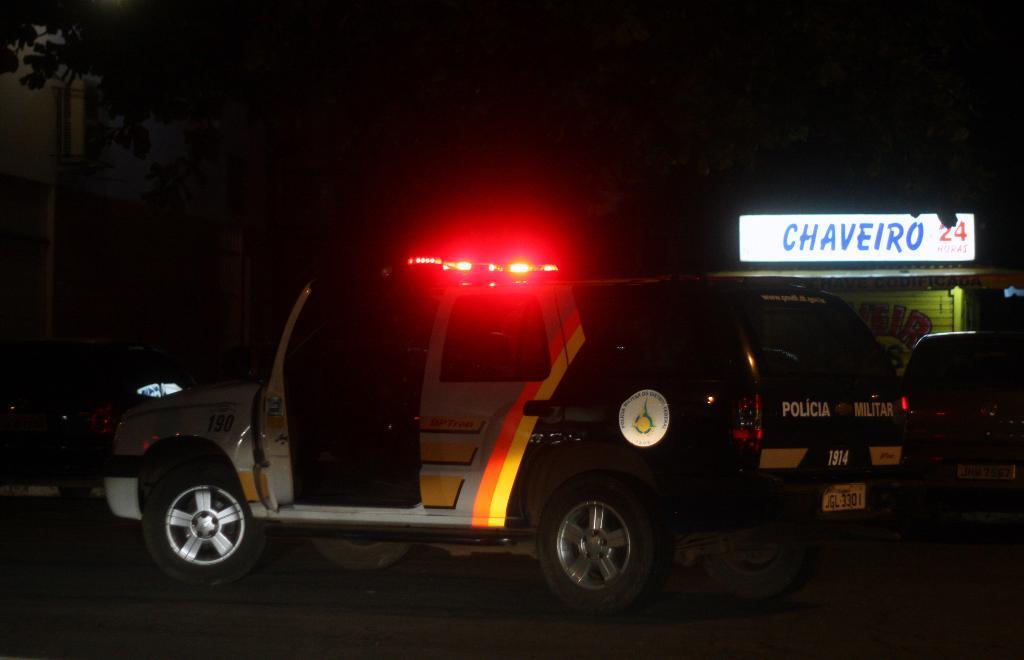Can you describe this image briefly? In this picture we can see a car and lights here, in the background we can see a hoarding here, we can see dark background. 